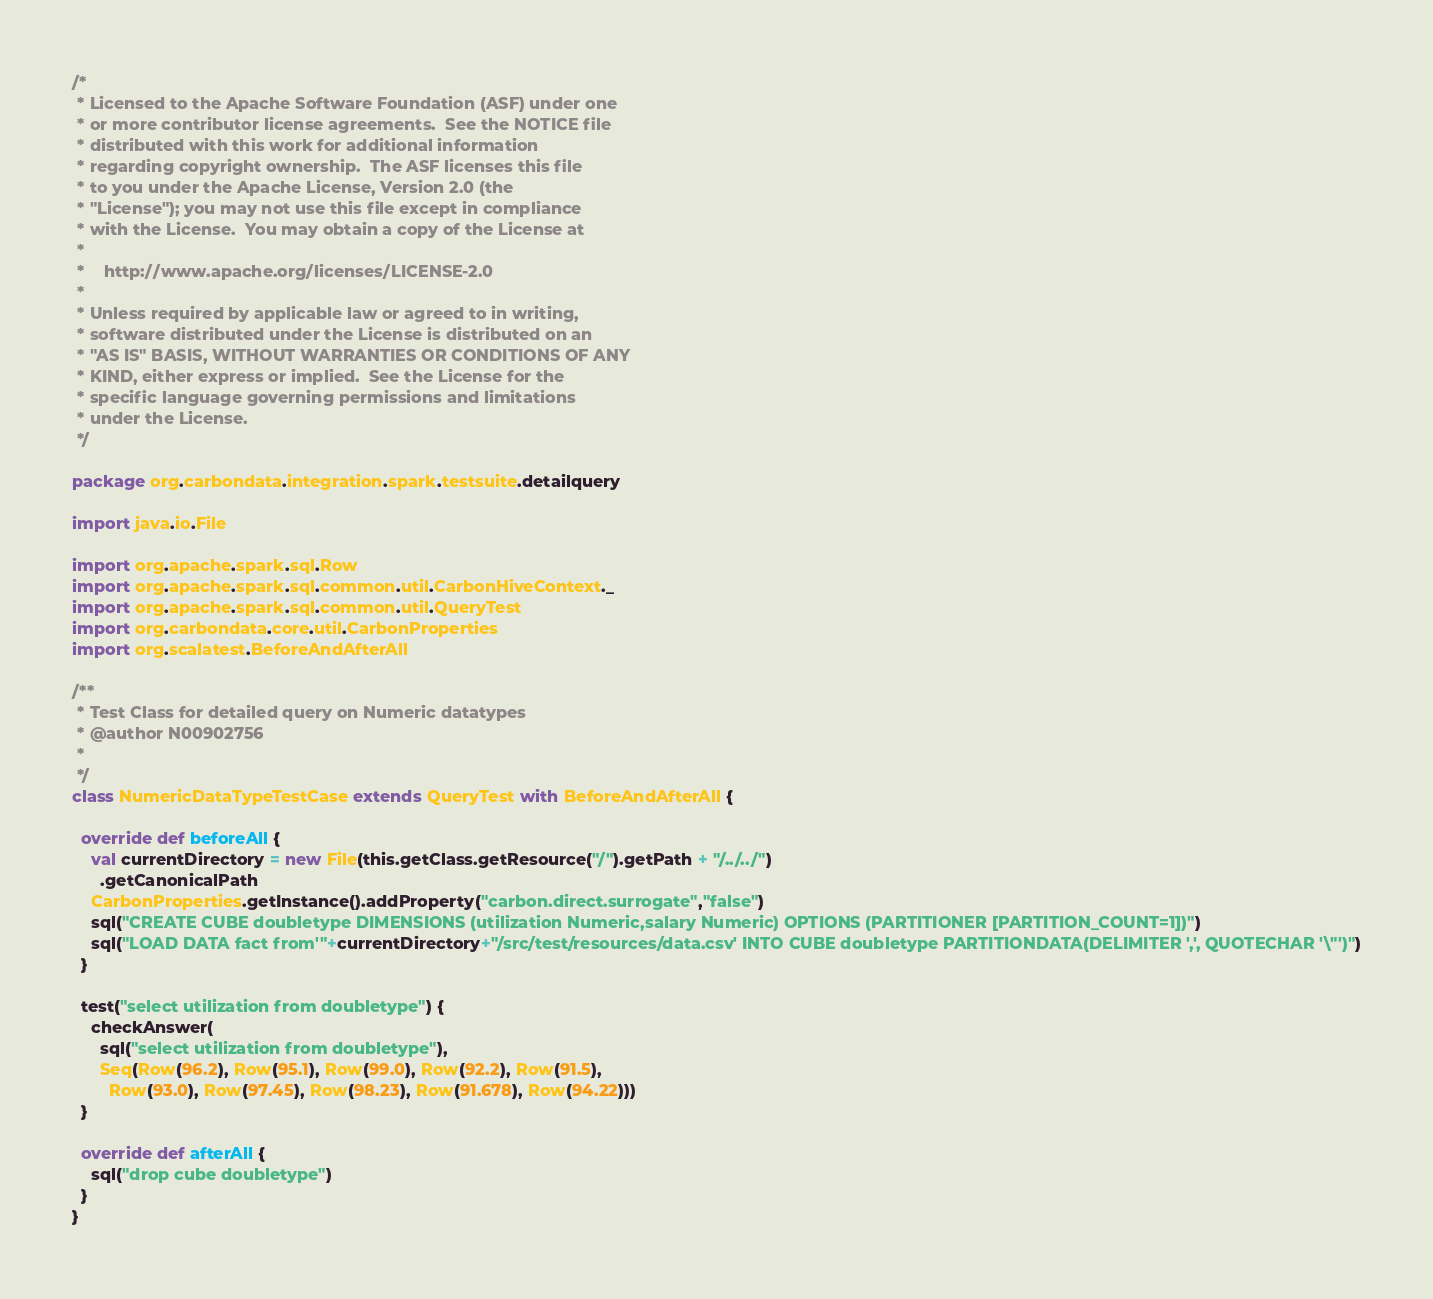Convert code to text. <code><loc_0><loc_0><loc_500><loc_500><_Scala_>/*
 * Licensed to the Apache Software Foundation (ASF) under one
 * or more contributor license agreements.  See the NOTICE file
 * distributed with this work for additional information
 * regarding copyright ownership.  The ASF licenses this file
 * to you under the Apache License, Version 2.0 (the
 * "License"); you may not use this file except in compliance
 * with the License.  You may obtain a copy of the License at
 *
 *    http://www.apache.org/licenses/LICENSE-2.0
 *
 * Unless required by applicable law or agreed to in writing,
 * software distributed under the License is distributed on an
 * "AS IS" BASIS, WITHOUT WARRANTIES OR CONDITIONS OF ANY
 * KIND, either express or implied.  See the License for the
 * specific language governing permissions and limitations
 * under the License.
 */

package org.carbondata.integration.spark.testsuite.detailquery

import java.io.File

import org.apache.spark.sql.Row
import org.apache.spark.sql.common.util.CarbonHiveContext._
import org.apache.spark.sql.common.util.QueryTest
import org.carbondata.core.util.CarbonProperties
import org.scalatest.BeforeAndAfterAll

/**
 * Test Class for detailed query on Numeric datatypes
 * @author N00902756
 *
 */
class NumericDataTypeTestCase extends QueryTest with BeforeAndAfterAll {

  override def beforeAll {
    val currentDirectory = new File(this.getClass.getResource("/").getPath + "/../../")
      .getCanonicalPath
    CarbonProperties.getInstance().addProperty("carbon.direct.surrogate","false")
    sql("CREATE CUBE doubletype DIMENSIONS (utilization Numeric,salary Numeric) OPTIONS (PARTITIONER [PARTITION_COUNT=1])")
    sql("LOAD DATA fact from'"+currentDirectory+"/src/test/resources/data.csv' INTO CUBE doubletype PARTITIONDATA(DELIMITER ',', QUOTECHAR '\"')")
  }

  test("select utilization from doubletype") {
    checkAnswer(
      sql("select utilization from doubletype"),
      Seq(Row(96.2), Row(95.1), Row(99.0), Row(92.2), Row(91.5),
        Row(93.0), Row(97.45), Row(98.23), Row(91.678), Row(94.22)))
  }

  override def afterAll {
    sql("drop cube doubletype")
  }
}</code> 